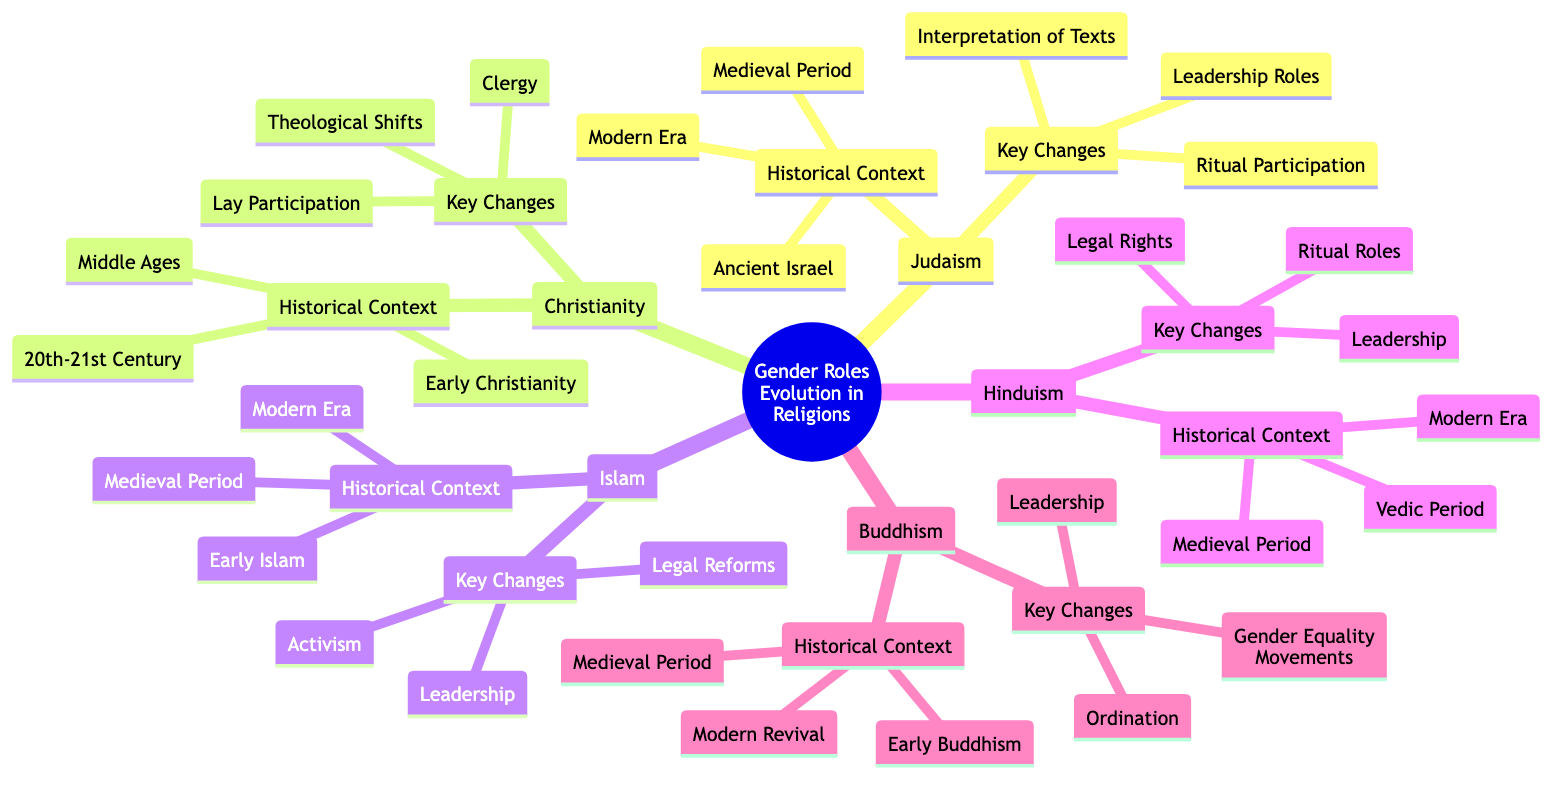What is the central topic of the mind map? The central topic is clearly stated at the root of the mind map as "The Evolution of Gender Roles in Different Religions with Historical Context."
Answer: The Evolution of Gender Roles in Different Religions with Historical Context How many branches are there in the diagram? The main branches are Judaism, Christianity, Islam, Hinduism, and Buddhism, giving a total of five branches extending from the central topic.
Answer: 5 Which religion's historical context mentions "Patriarchal society with defined gender roles"? The historical context under Judaism refers to "Ancient Israel," which is described as a patriarchal society with defined gender roles.
Answer: Judaism What key change occurred in Christianity during the 20th-21st Century? The "Emergence of feminist theology and women's ordination" is noted as a significant key change in the historical context of Christianity for this era.
Answer: Emergence of feminist theology and women's ordination Name one prominent female leader in Islam mentioned in the diagram. The diagram mentions Amina Wadud as a significant emergence of women scholars and imams in the context of key changes for Islam.
Answer: Amina Wadud What was a role of women during the Vedic Period in Hinduism? The diagram states that women participated in religious rituals and philosophical debates during the Vedic Period, highlighting their active role in religious practices.
Answer: Participated in religious rituals and philosophical debates What major change happened in Buddhism in the "Modern Revival"? The revival of full ordination for women in Theravada and other traditions is the major change noted in Buddhism during the "Modern Revival."
Answer: Revival of full ordination for women How did the status of women in Christianity change from early Christianity to the Middle Ages? The diagram suggests that while women held some leadership roles in Early Christianity, strict gender roles were reinforced by Church laws during the Middle Ages, indicating a regression in their status.
Answer: Strict gender roles reinforced by Church laws What is the relationship between "Leadership" and "Activism" in the context of Islamic reforms? Both "Leadership" (emergence of women scholars and imams) and "Activism" (women's rights movements) are key changes listed under Islam, indicating a correlation between increased recognition of women in leadership roles and advocacy for women's rights within Muslim communities.
Answer: Leadership and Activism are correlated 